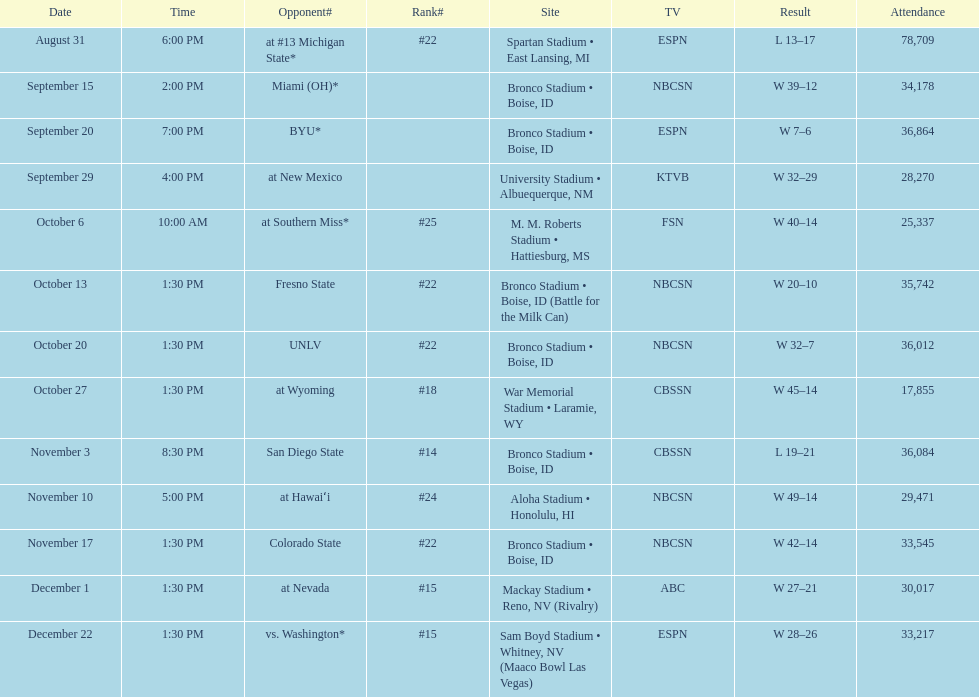In the latest winning games for boise state, how many points were scored in total? 146. 